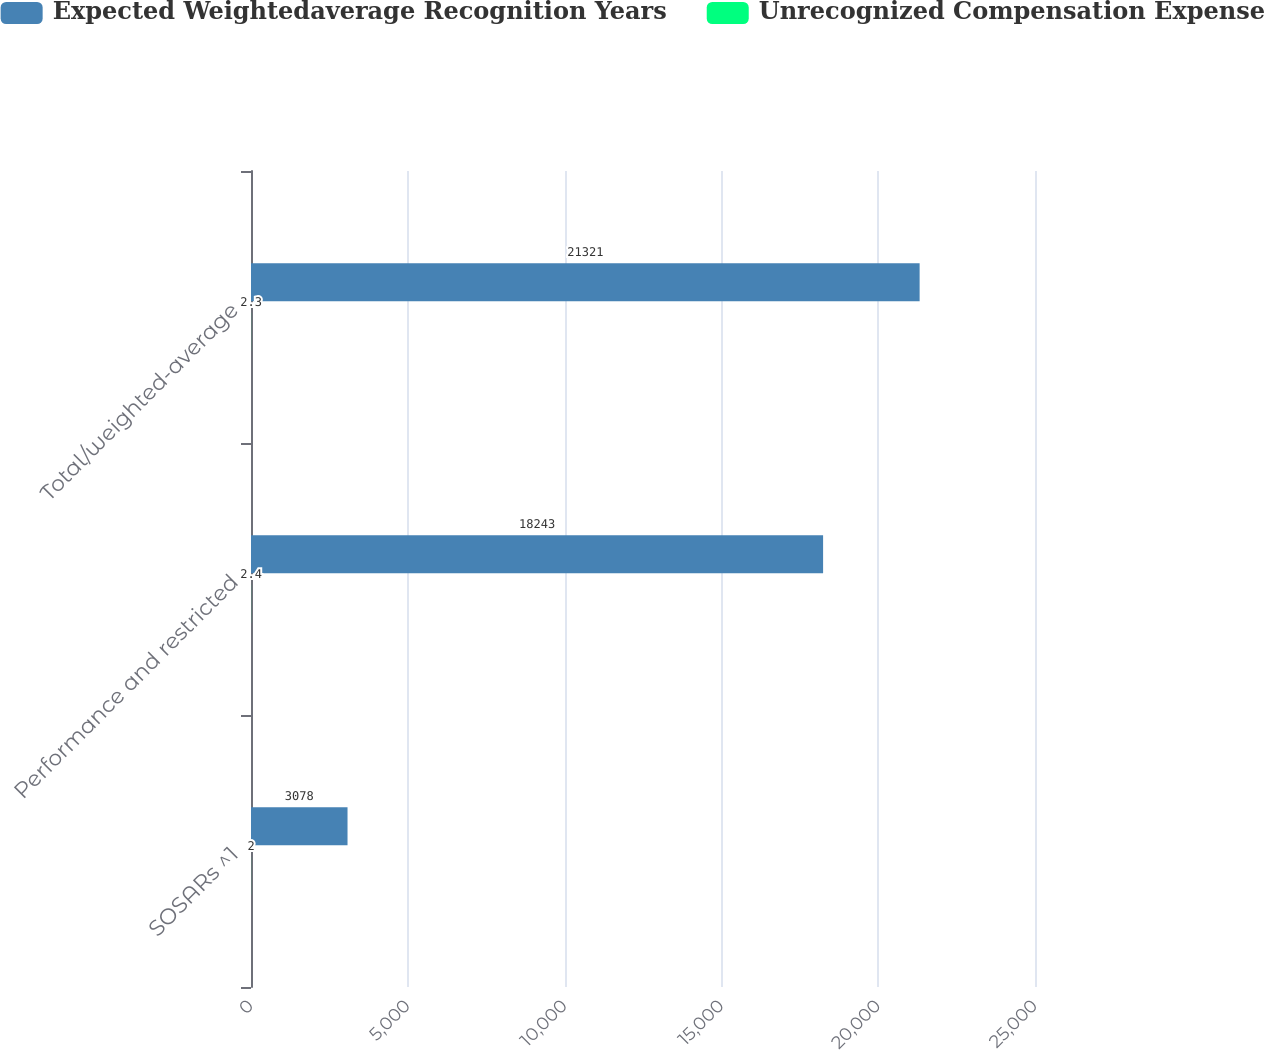Convert chart to OTSL. <chart><loc_0><loc_0><loc_500><loc_500><stacked_bar_chart><ecel><fcel>SOSARs ^1<fcel>Performance and restricted<fcel>Total/weighted-average<nl><fcel>Expected Weightedaverage Recognition Years<fcel>3078<fcel>18243<fcel>21321<nl><fcel>Unrecognized Compensation Expense<fcel>2<fcel>2.4<fcel>2.3<nl></chart> 